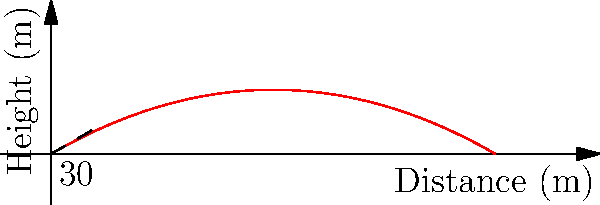As a marketing specialist promoting a golf course, you want to highlight the physics behind a perfect golf swing. If a golfer hits a ball with an initial velocity of 50 m/s at a 30° angle above the horizontal, what is the maximum height reached by the golf ball? (Use g = 9.8 m/s²) To find the maximum height of the golf ball's trajectory, we'll follow these steps:

1) The vertical component of the initial velocity is:
   $v_{0y} = v_0 \sin(\theta) = 50 \sin(30°) = 25$ m/s

2) The time to reach the maximum height is when the vertical velocity becomes zero:
   $t_{max} = \frac{v_{0y}}{g} = \frac{25}{9.8} = 2.55$ s

3) The maximum height can be calculated using the equation:
   $h_{max} = v_{0y}t - \frac{1}{2}gt^2$

4) Substituting the values:
   $h_{max} = 25(2.55) - \frac{1}{2}(9.8)(2.55)^2$
   $h_{max} = 63.75 - 31.87 = 31.88$ m

Therefore, the maximum height reached by the golf ball is approximately 31.88 meters.
Answer: 31.88 meters 